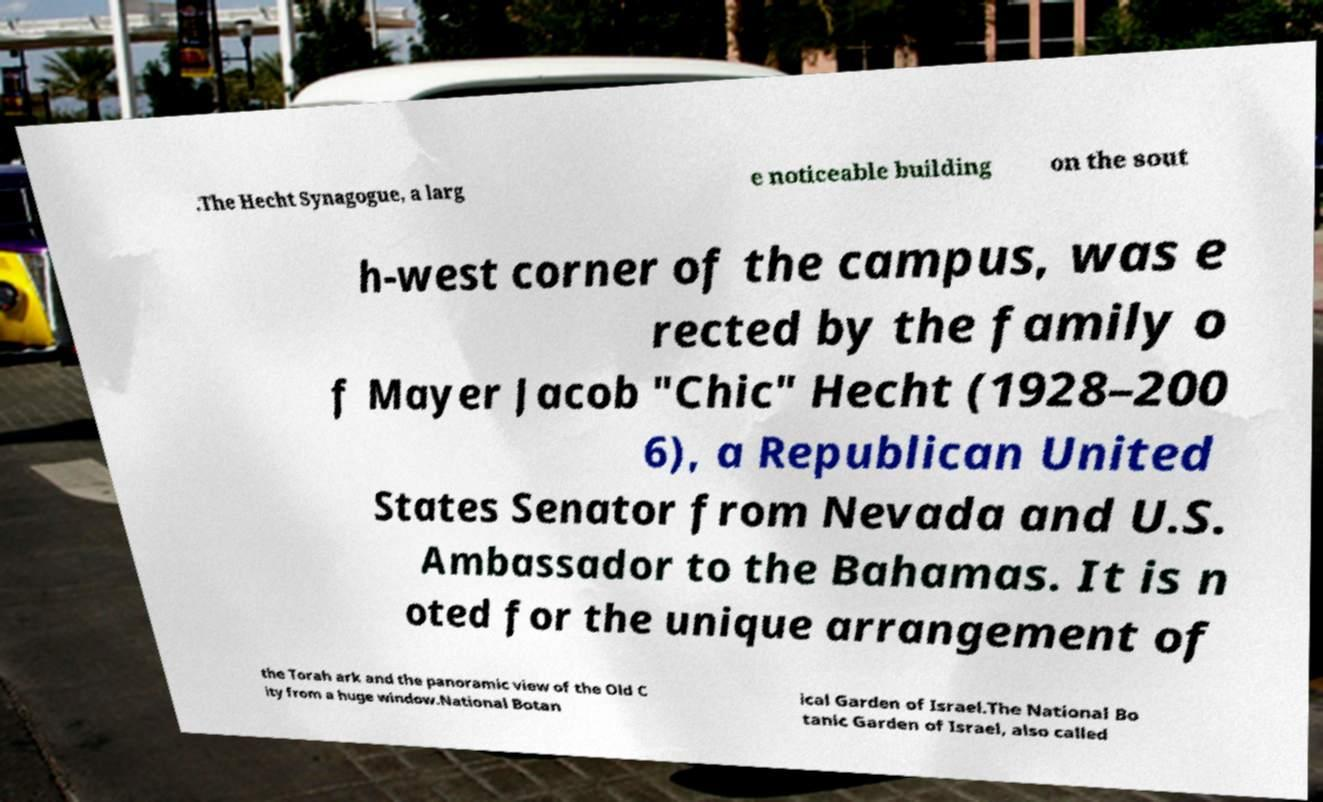What messages or text are displayed in this image? I need them in a readable, typed format. .The Hecht Synagogue, a larg e noticeable building on the sout h-west corner of the campus, was e rected by the family o f Mayer Jacob "Chic" Hecht (1928–200 6), a Republican United States Senator from Nevada and U.S. Ambassador to the Bahamas. It is n oted for the unique arrangement of the Torah ark and the panoramic view of the Old C ity from a huge window.National Botan ical Garden of Israel.The National Bo tanic Garden of Israel, also called 